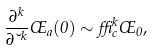<formula> <loc_0><loc_0><loc_500><loc_500>\frac { \partial ^ { k } } { \partial \lambda ^ { k } } \phi _ { a } ( 0 ) \sim \delta ^ { k } _ { c } \phi _ { 0 } ,</formula> 